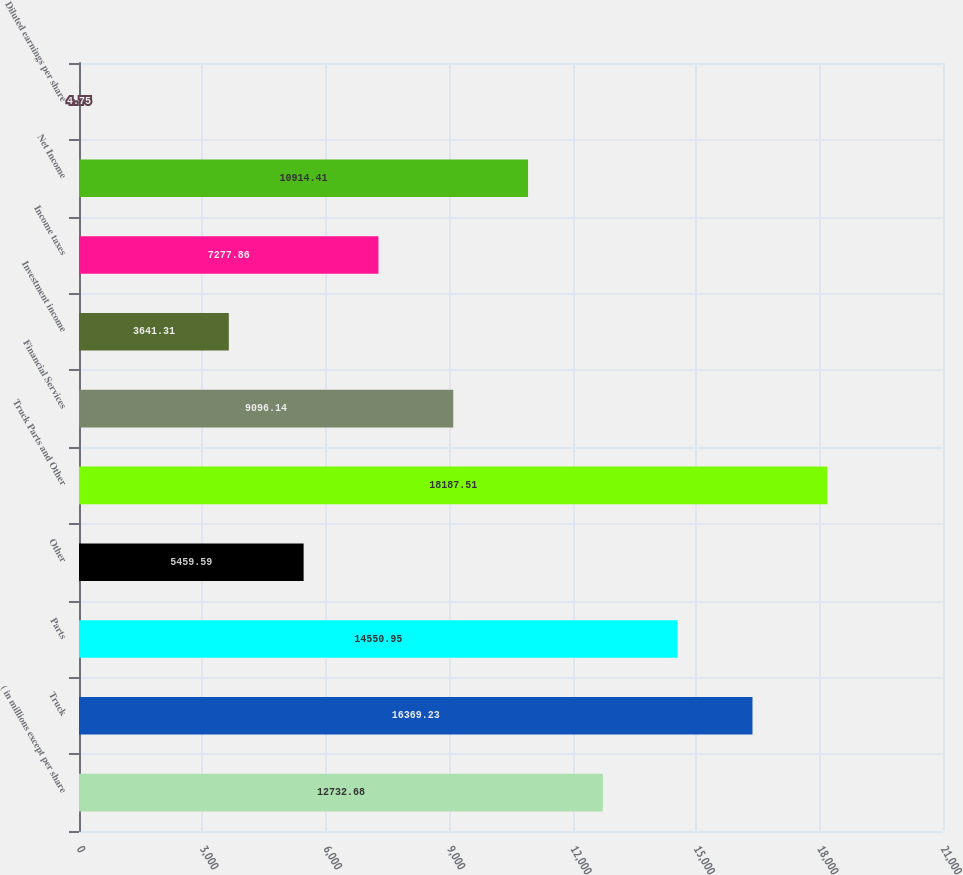Convert chart to OTSL. <chart><loc_0><loc_0><loc_500><loc_500><bar_chart><fcel>( in millions except per share<fcel>Truck<fcel>Parts<fcel>Other<fcel>Truck Parts and Other<fcel>Financial Services<fcel>Investment income<fcel>Income taxes<fcel>Net Income<fcel>Diluted earnings per share<nl><fcel>12732.7<fcel>16369.2<fcel>14551<fcel>5459.59<fcel>18187.5<fcel>9096.14<fcel>3641.31<fcel>7277.86<fcel>10914.4<fcel>4.75<nl></chart> 